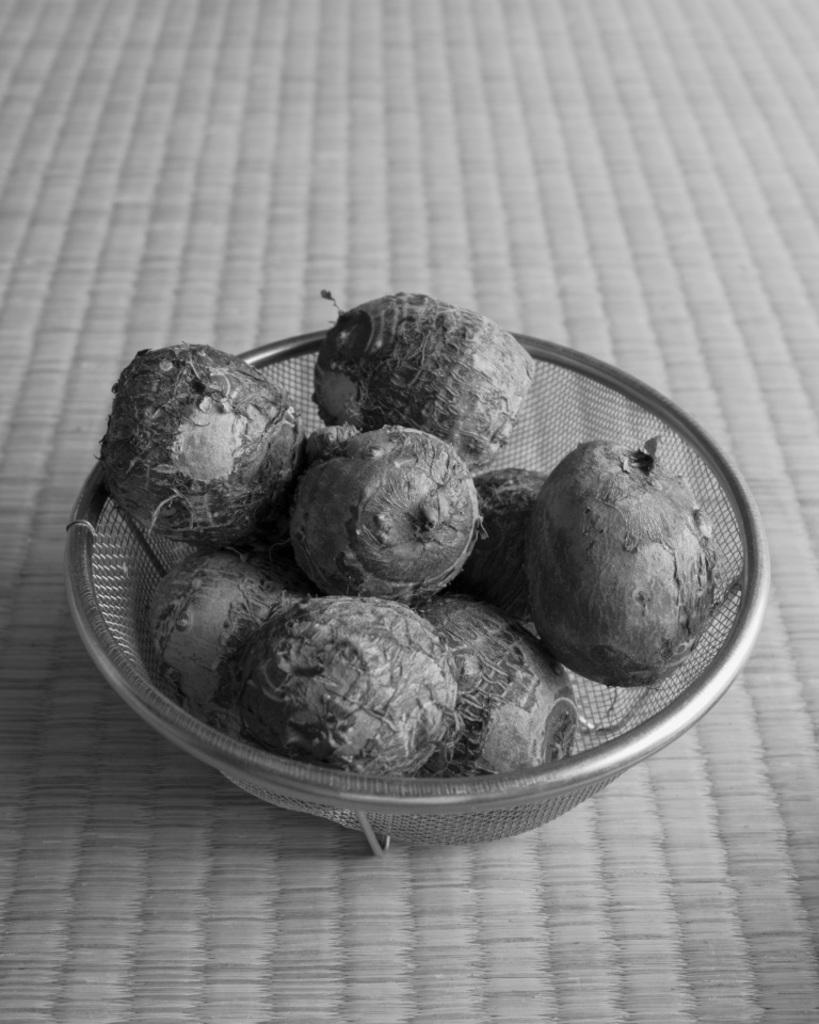What is the color scheme of the image? The image is black and white. What type of vegetable is present in the image? There is beetroot in the image. In what type of container is the beetroot placed? The beetroot is in a metal bowl. What type of theory is being discussed in the image? There is no discussion or theory present in the image; it features a black and white image of beetroot in a metal bowl. 